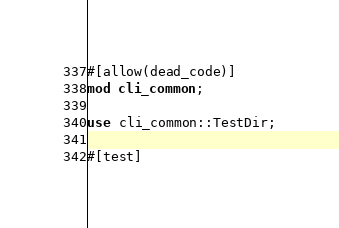Convert code to text. <code><loc_0><loc_0><loc_500><loc_500><_Rust_>#[allow(dead_code)]
mod cli_common;

use cli_common::TestDir;

#[test]</code> 